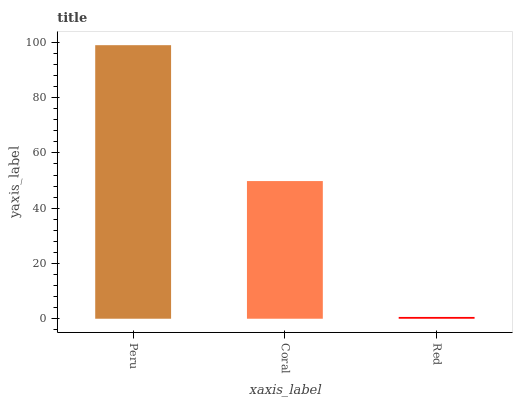Is Red the minimum?
Answer yes or no. Yes. Is Peru the maximum?
Answer yes or no. Yes. Is Coral the minimum?
Answer yes or no. No. Is Coral the maximum?
Answer yes or no. No. Is Peru greater than Coral?
Answer yes or no. Yes. Is Coral less than Peru?
Answer yes or no. Yes. Is Coral greater than Peru?
Answer yes or no. No. Is Peru less than Coral?
Answer yes or no. No. Is Coral the high median?
Answer yes or no. Yes. Is Coral the low median?
Answer yes or no. Yes. Is Red the high median?
Answer yes or no. No. Is Red the low median?
Answer yes or no. No. 